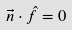Convert formula to latex. <formula><loc_0><loc_0><loc_500><loc_500>\vec { n } \cdot \hat { f } = 0</formula> 